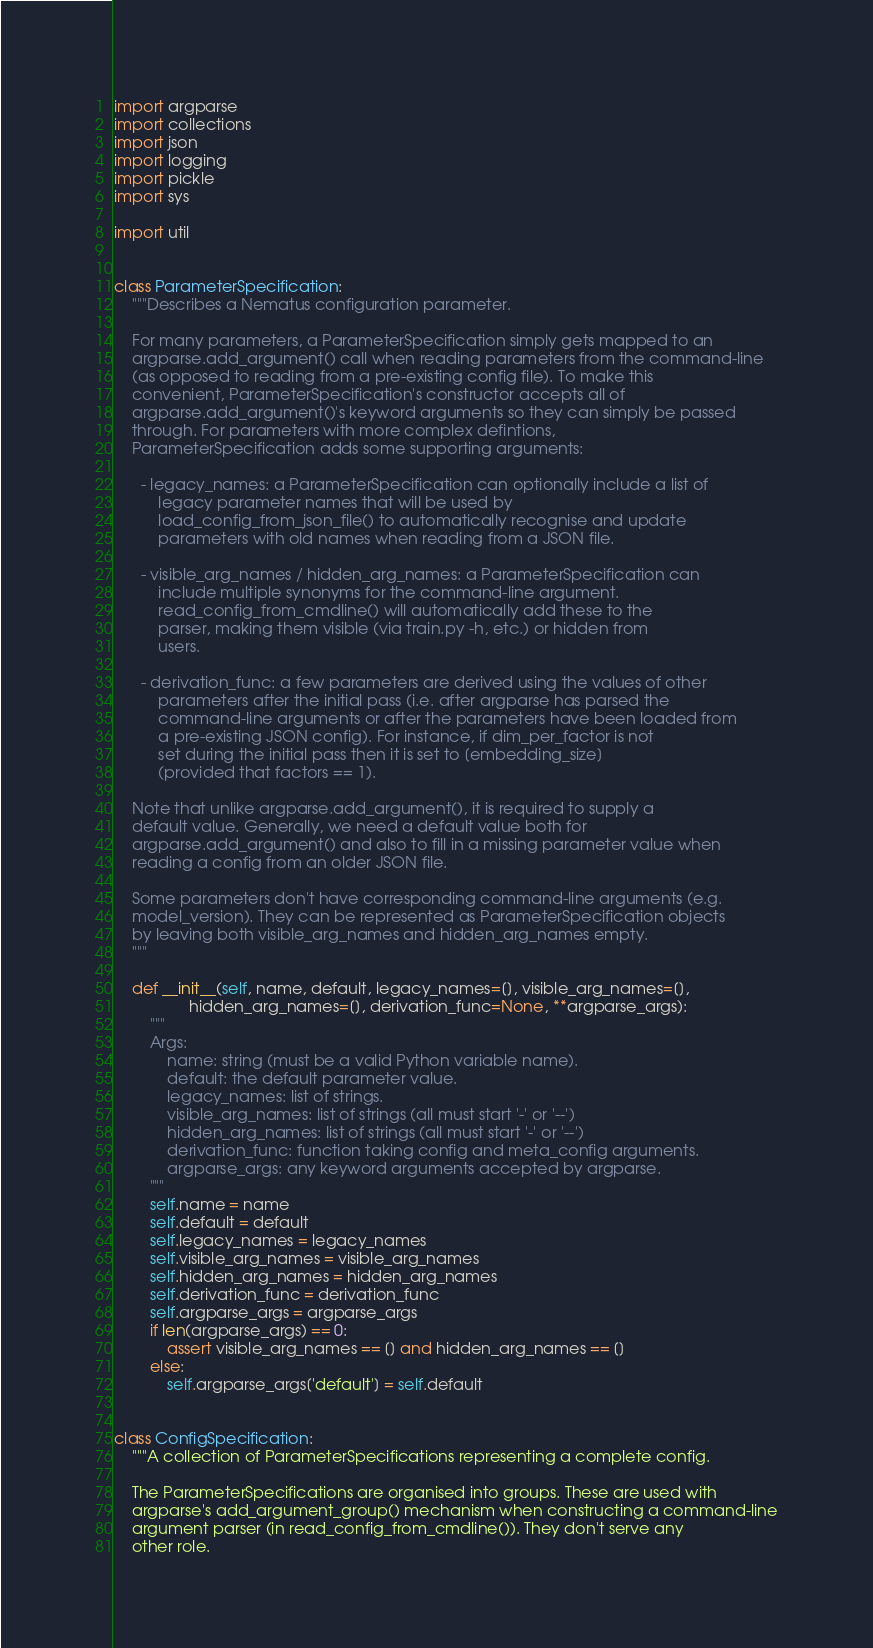Convert code to text. <code><loc_0><loc_0><loc_500><loc_500><_Python_>import argparse
import collections
import json
import logging
import pickle
import sys

import util


class ParameterSpecification:
    """Describes a Nematus configuration parameter.

    For many parameters, a ParameterSpecification simply gets mapped to an
    argparse.add_argument() call when reading parameters from the command-line
    (as opposed to reading from a pre-existing config file). To make this
    convenient, ParameterSpecification's constructor accepts all of
    argparse.add_argument()'s keyword arguments so they can simply be passed
    through. For parameters with more complex defintions,
    ParameterSpecification adds some supporting arguments:

      - legacy_names: a ParameterSpecification can optionally include a list of
          legacy parameter names that will be used by
          load_config_from_json_file() to automatically recognise and update
          parameters with old names when reading from a JSON file.

      - visible_arg_names / hidden_arg_names: a ParameterSpecification can
          include multiple synonyms for the command-line argument.
          read_config_from_cmdline() will automatically add these to the
          parser, making them visible (via train.py -h, etc.) or hidden from
          users.

      - derivation_func: a few parameters are derived using the values of other
          parameters after the initial pass (i.e. after argparse has parsed the
          command-line arguments or after the parameters have been loaded from
          a pre-existing JSON config). For instance, if dim_per_factor is not
          set during the initial pass then it is set to [embedding_size]
          (provided that factors == 1).

    Note that unlike argparse.add_argument(), it is required to supply a
    default value. Generally, we need a default value both for
    argparse.add_argument() and also to fill in a missing parameter value when
    reading a config from an older JSON file.

    Some parameters don't have corresponding command-line arguments (e.g.
    model_version). They can be represented as ParameterSpecification objects
    by leaving both visible_arg_names and hidden_arg_names empty.
    """

    def __init__(self, name, default, legacy_names=[], visible_arg_names=[],
                 hidden_arg_names=[], derivation_func=None, **argparse_args):
        """
        Args:
            name: string (must be a valid Python variable name).
            default: the default parameter value.
            legacy_names: list of strings.
            visible_arg_names: list of strings (all must start '-' or '--')
            hidden_arg_names: list of strings (all must start '-' or '--')
            derivation_func: function taking config and meta_config arguments.
            argparse_args: any keyword arguments accepted by argparse.
        """
        self.name = name
        self.default = default
        self.legacy_names = legacy_names
        self.visible_arg_names = visible_arg_names
        self.hidden_arg_names = hidden_arg_names
        self.derivation_func = derivation_func
        self.argparse_args = argparse_args
        if len(argparse_args) == 0:
            assert visible_arg_names == [] and hidden_arg_names == []
        else:
            self.argparse_args['default'] = self.default


class ConfigSpecification:
    """A collection of ParameterSpecifications representing a complete config.

    The ParameterSpecifications are organised into groups. These are used with
    argparse's add_argument_group() mechanism when constructing a command-line
    argument parser (in read_config_from_cmdline()). They don't serve any
    other role.
</code> 